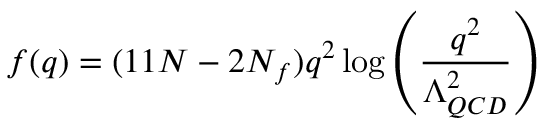<formula> <loc_0><loc_0><loc_500><loc_500>f ( q ) = ( 1 1 N - 2 N _ { f } ) q ^ { 2 } \log \left ( \frac { q ^ { 2 } } { \Lambda _ { Q C D } ^ { 2 } } \right )</formula> 